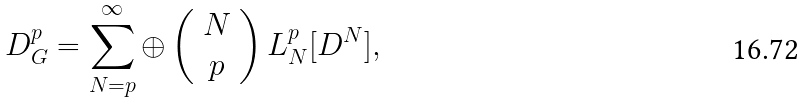Convert formula to latex. <formula><loc_0><loc_0><loc_500><loc_500>D ^ { p } _ { G } = \sum _ { N = p } ^ { \infty } \oplus \left ( \begin{array} { c } N \\ p \end{array} \right ) L _ { N } ^ { p } [ D ^ { N } ] ,</formula> 